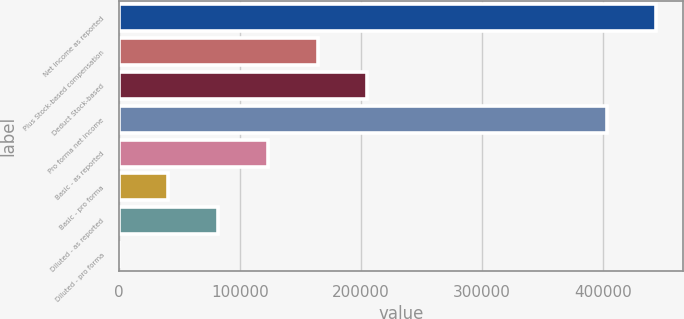Convert chart to OTSL. <chart><loc_0><loc_0><loc_500><loc_500><bar_chart><fcel>Net income as reported<fcel>Plus Stock-based compensation<fcel>Deduct Stock-based<fcel>Pro forma net income<fcel>Basic - as reported<fcel>Basic - pro forma<fcel>Diluted - as reported<fcel>Diluted - pro forma<nl><fcel>443669<fcel>164239<fcel>205298<fcel>402610<fcel>123180<fcel>41062.3<fcel>82121.1<fcel>3.4<nl></chart> 